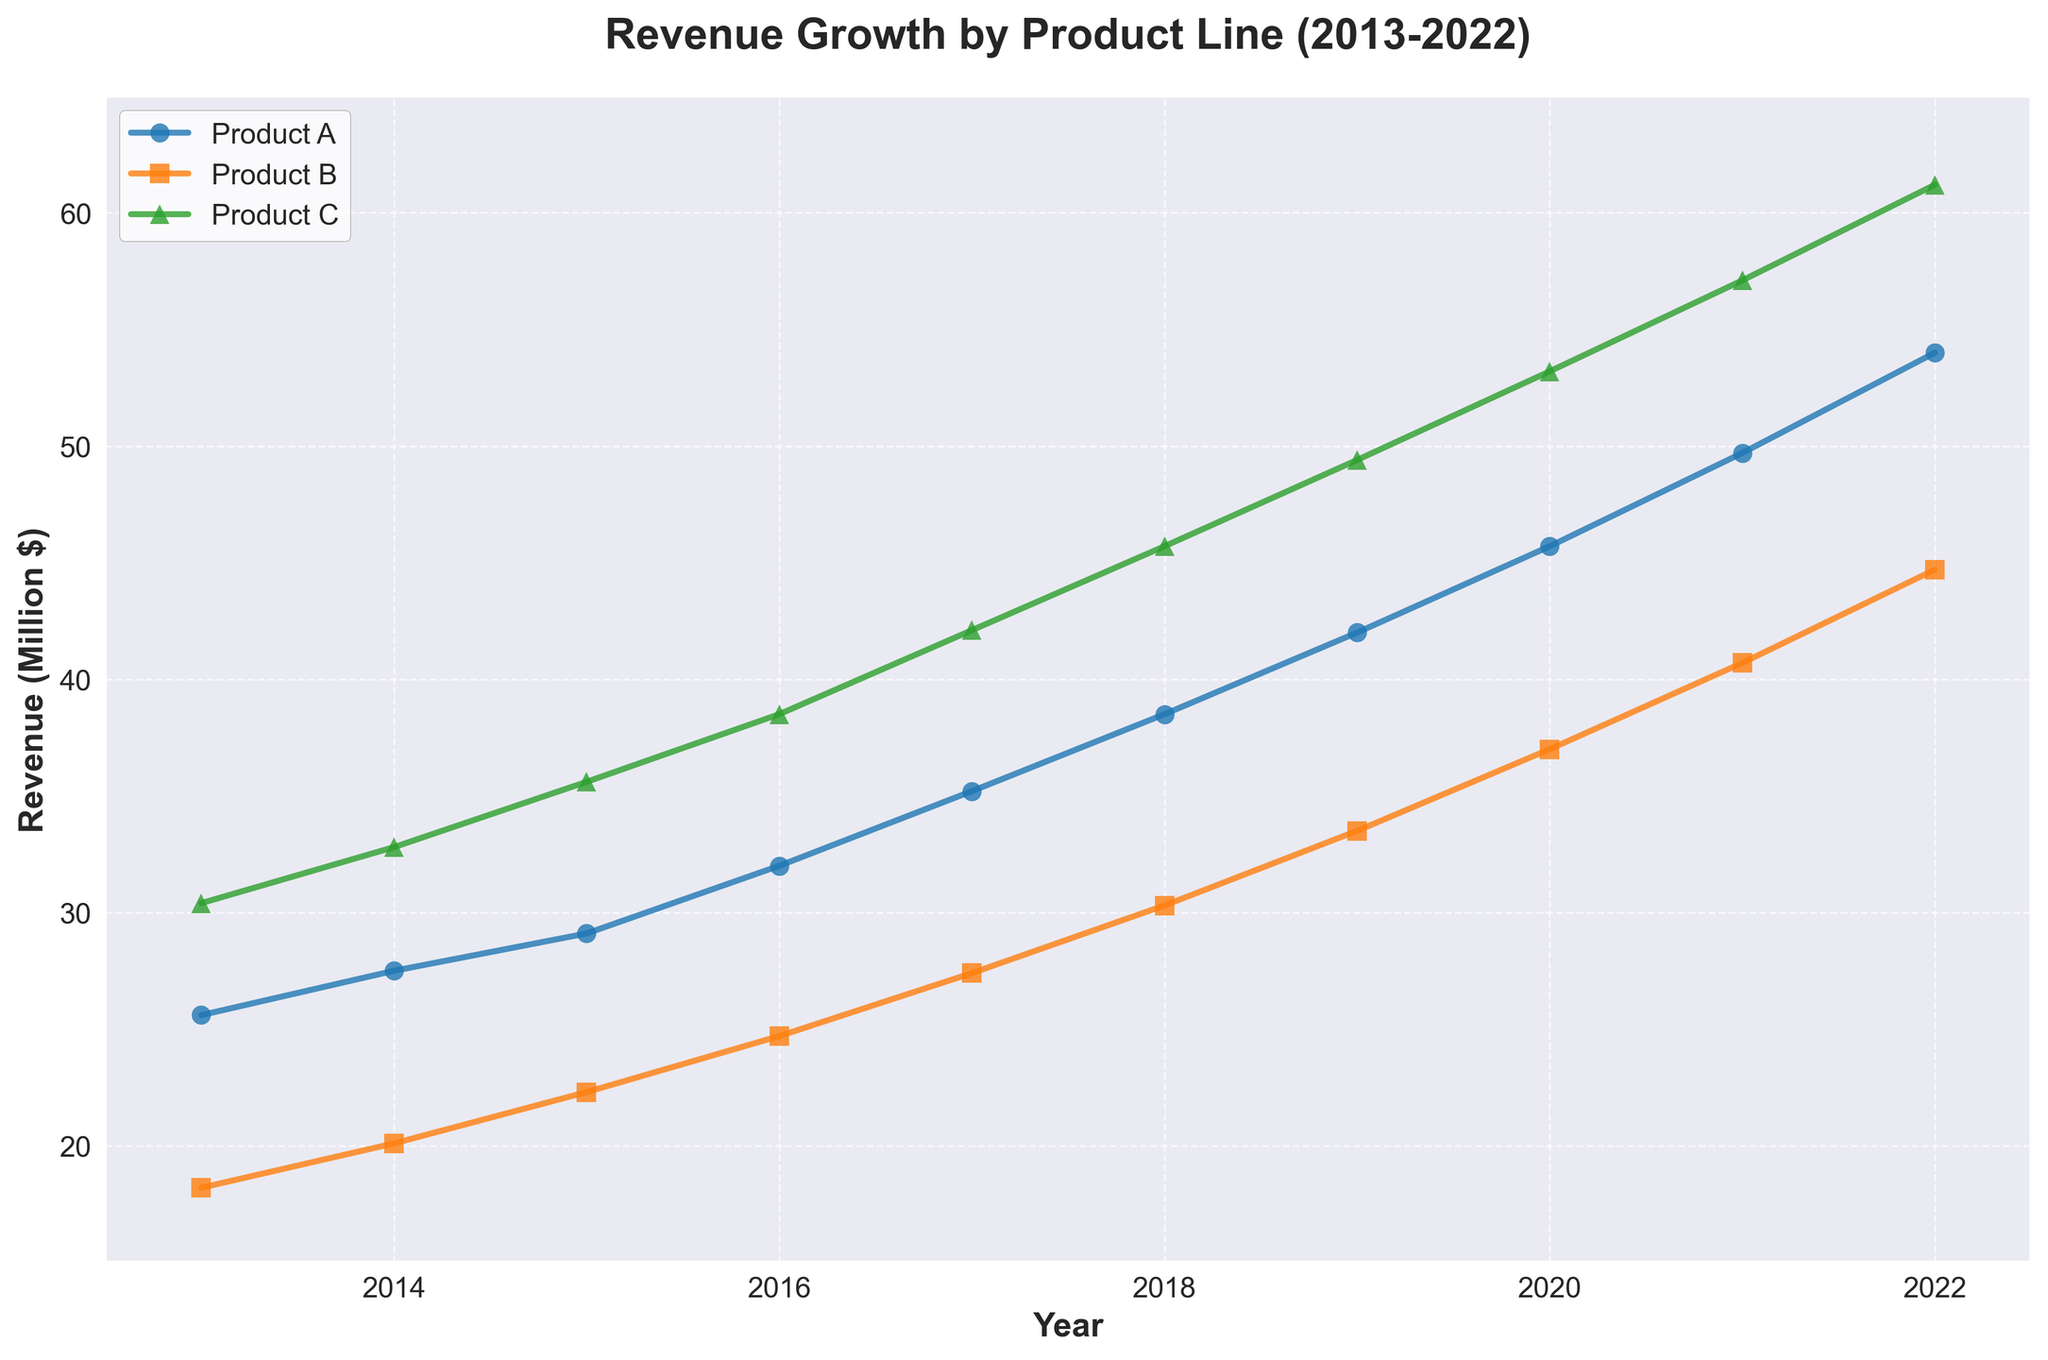what's the title of the figure? The title of the figure is prominently displayed at the top.
Answer: Revenue Growth by Product Line (2013-2022) what's the revenue for Product B in 2019? To find this, look at the intersection of the Product B line with the year 2019 on the x-axis.
Answer: 33.5 which product had the highest revenue in 2021? Compare the points for each product line in the year 2021 and identify the highest.
Answer: Product C how many different product lines are shown in the figure? The legend lists all unique product lines plotted in the graph.
Answer: 3 what is the total revenue of Product A and Product B combined in 2016? Add the revenue values of Product A and Product B for the year 2016: 32.0 (Product A) + 24.7 (Product B).
Answer: 56.7 in which year did Product C first surpass 50 million dollars in revenue? Examine the plot of Product C and find the first year when the y-value exceeds 50 million.
Answer: 2020 which product had the steepest growth between 2013 and 2022? Evaluate the slope of the lines representing each product from 2013 to 2022; the steepest slope indicates the highest growth rate.
Answer: Product C how much did the revenue of Product A increase from 2013 to 2022? Subtract the revenue of Product A in 2013 from the revenue in 2022: 54.0 - 25.6.
Answer: 28.4 did any product experience a decline in revenue in any consecutive year? Check the plot for each product line and look for instances where the line dips between two years.
Answer: No are all products showing a consistent increasing revenue trend throughout the decade? Evaluate the lines for each product and check for consistent upward trends without any declines.
Answer: Yes 